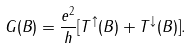Convert formula to latex. <formula><loc_0><loc_0><loc_500><loc_500>G ( B ) = \frac { e ^ { 2 } } { h } [ T ^ { \uparrow } ( B ) + T ^ { \downarrow } ( B ) ] .</formula> 